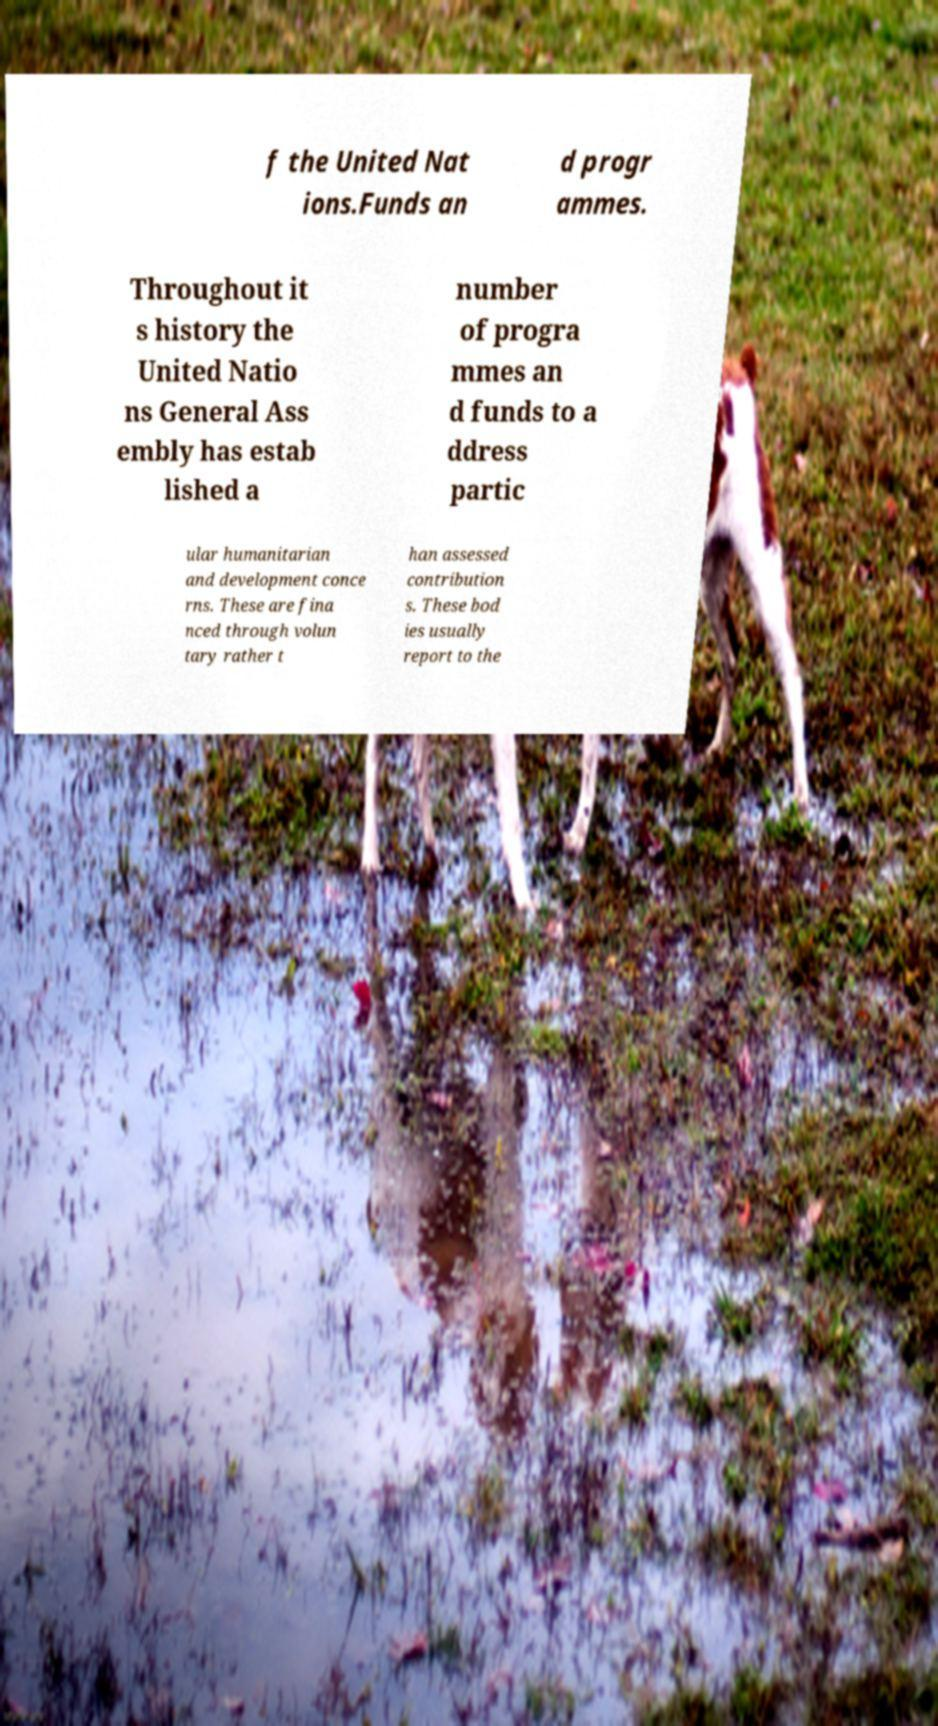Could you extract and type out the text from this image? f the United Nat ions.Funds an d progr ammes. Throughout it s history the United Natio ns General Ass embly has estab lished a number of progra mmes an d funds to a ddress partic ular humanitarian and development conce rns. These are fina nced through volun tary rather t han assessed contribution s. These bod ies usually report to the 